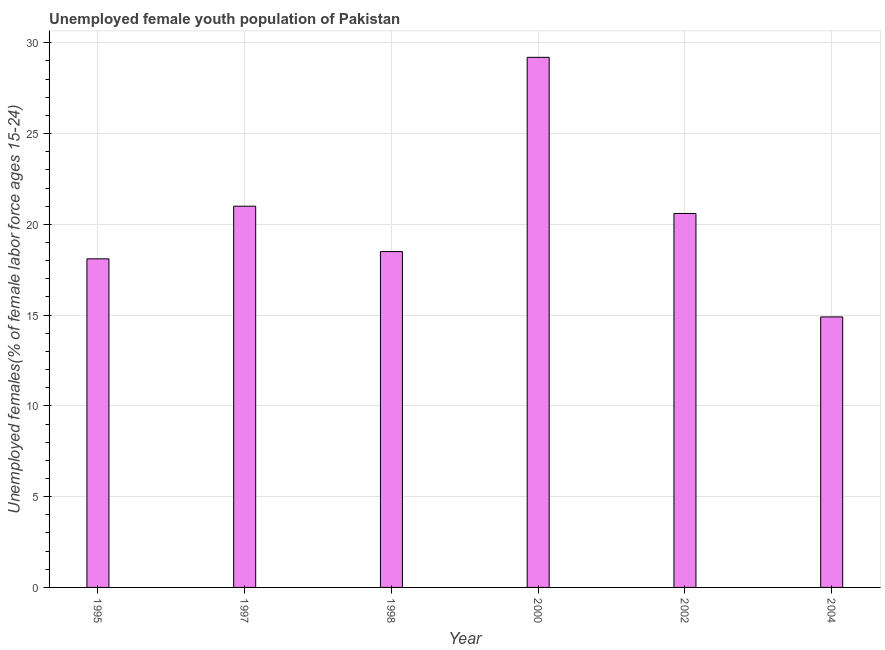Does the graph contain any zero values?
Offer a terse response. No. Does the graph contain grids?
Your answer should be very brief. Yes. What is the title of the graph?
Give a very brief answer. Unemployed female youth population of Pakistan. What is the label or title of the X-axis?
Your answer should be very brief. Year. What is the label or title of the Y-axis?
Offer a very short reply. Unemployed females(% of female labor force ages 15-24). What is the unemployed female youth in 2004?
Ensure brevity in your answer.  14.9. Across all years, what is the maximum unemployed female youth?
Keep it short and to the point. 29.2. Across all years, what is the minimum unemployed female youth?
Provide a short and direct response. 14.9. In which year was the unemployed female youth minimum?
Offer a terse response. 2004. What is the sum of the unemployed female youth?
Your answer should be compact. 122.3. What is the average unemployed female youth per year?
Keep it short and to the point. 20.38. What is the median unemployed female youth?
Ensure brevity in your answer.  19.55. In how many years, is the unemployed female youth greater than 10 %?
Your response must be concise. 6. What is the ratio of the unemployed female youth in 1997 to that in 2000?
Make the answer very short. 0.72. Is the unemployed female youth in 1995 less than that in 1997?
Your answer should be very brief. Yes. What is the difference between the highest and the second highest unemployed female youth?
Your answer should be very brief. 8.2. In how many years, is the unemployed female youth greater than the average unemployed female youth taken over all years?
Make the answer very short. 3. How many bars are there?
Provide a succinct answer. 6. What is the Unemployed females(% of female labor force ages 15-24) in 1995?
Provide a succinct answer. 18.1. What is the Unemployed females(% of female labor force ages 15-24) in 1997?
Provide a short and direct response. 21. What is the Unemployed females(% of female labor force ages 15-24) of 2000?
Make the answer very short. 29.2. What is the Unemployed females(% of female labor force ages 15-24) in 2002?
Your response must be concise. 20.6. What is the Unemployed females(% of female labor force ages 15-24) of 2004?
Ensure brevity in your answer.  14.9. What is the difference between the Unemployed females(% of female labor force ages 15-24) in 1995 and 1998?
Your answer should be very brief. -0.4. What is the difference between the Unemployed females(% of female labor force ages 15-24) in 1995 and 2000?
Your answer should be very brief. -11.1. What is the difference between the Unemployed females(% of female labor force ages 15-24) in 1995 and 2002?
Ensure brevity in your answer.  -2.5. What is the difference between the Unemployed females(% of female labor force ages 15-24) in 1995 and 2004?
Make the answer very short. 3.2. What is the difference between the Unemployed females(% of female labor force ages 15-24) in 1997 and 2002?
Give a very brief answer. 0.4. What is the difference between the Unemployed females(% of female labor force ages 15-24) in 1998 and 2000?
Provide a succinct answer. -10.7. What is the difference between the Unemployed females(% of female labor force ages 15-24) in 1998 and 2004?
Give a very brief answer. 3.6. What is the difference between the Unemployed females(% of female labor force ages 15-24) in 2000 and 2002?
Ensure brevity in your answer.  8.6. What is the difference between the Unemployed females(% of female labor force ages 15-24) in 2002 and 2004?
Offer a terse response. 5.7. What is the ratio of the Unemployed females(% of female labor force ages 15-24) in 1995 to that in 1997?
Make the answer very short. 0.86. What is the ratio of the Unemployed females(% of female labor force ages 15-24) in 1995 to that in 2000?
Your response must be concise. 0.62. What is the ratio of the Unemployed females(% of female labor force ages 15-24) in 1995 to that in 2002?
Your answer should be compact. 0.88. What is the ratio of the Unemployed females(% of female labor force ages 15-24) in 1995 to that in 2004?
Your answer should be compact. 1.22. What is the ratio of the Unemployed females(% of female labor force ages 15-24) in 1997 to that in 1998?
Make the answer very short. 1.14. What is the ratio of the Unemployed females(% of female labor force ages 15-24) in 1997 to that in 2000?
Make the answer very short. 0.72. What is the ratio of the Unemployed females(% of female labor force ages 15-24) in 1997 to that in 2002?
Offer a terse response. 1.02. What is the ratio of the Unemployed females(% of female labor force ages 15-24) in 1997 to that in 2004?
Give a very brief answer. 1.41. What is the ratio of the Unemployed females(% of female labor force ages 15-24) in 1998 to that in 2000?
Your answer should be compact. 0.63. What is the ratio of the Unemployed females(% of female labor force ages 15-24) in 1998 to that in 2002?
Provide a short and direct response. 0.9. What is the ratio of the Unemployed females(% of female labor force ages 15-24) in 1998 to that in 2004?
Make the answer very short. 1.24. What is the ratio of the Unemployed females(% of female labor force ages 15-24) in 2000 to that in 2002?
Ensure brevity in your answer.  1.42. What is the ratio of the Unemployed females(% of female labor force ages 15-24) in 2000 to that in 2004?
Give a very brief answer. 1.96. What is the ratio of the Unemployed females(% of female labor force ages 15-24) in 2002 to that in 2004?
Provide a succinct answer. 1.38. 